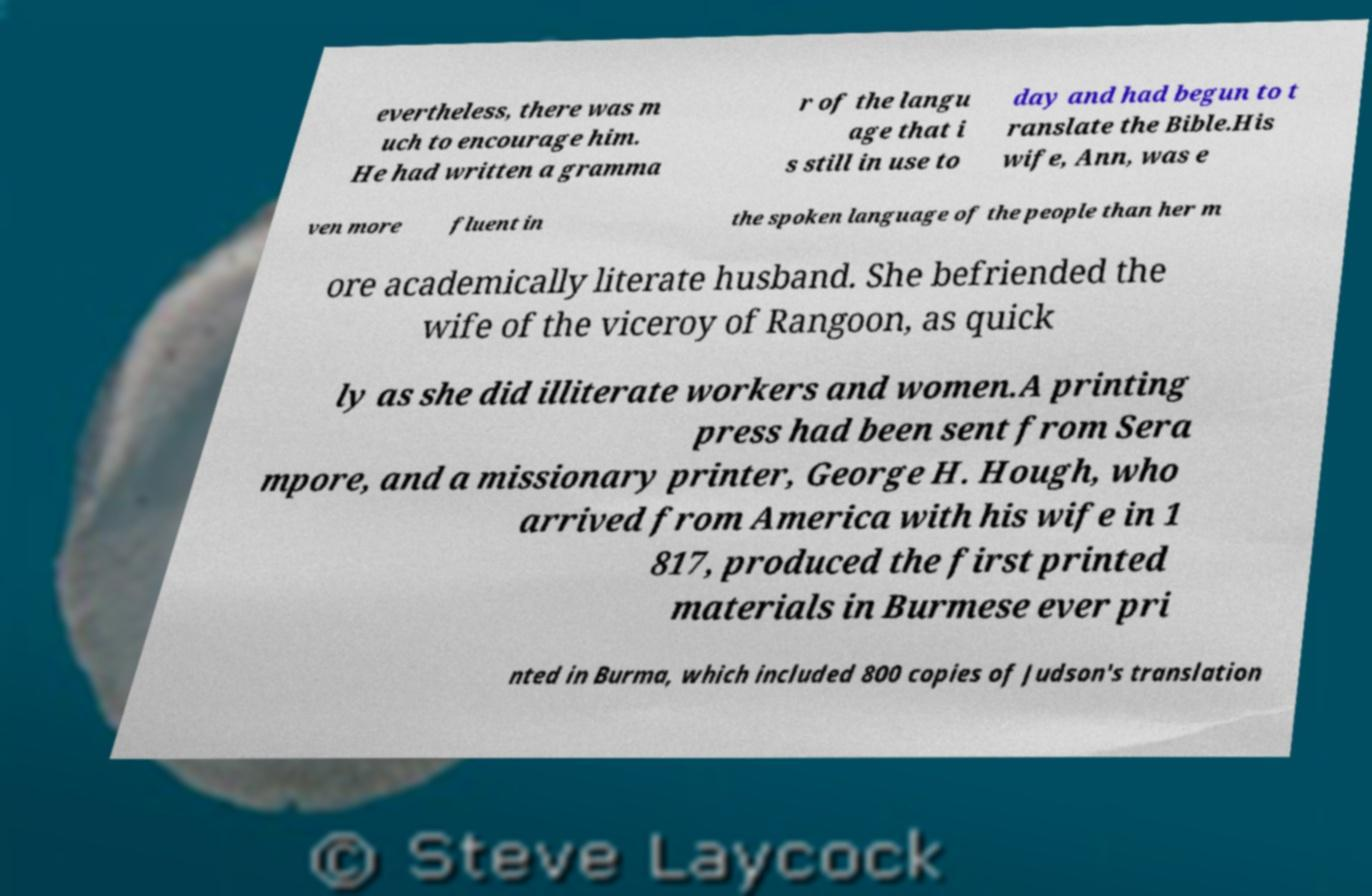For documentation purposes, I need the text within this image transcribed. Could you provide that? evertheless, there was m uch to encourage him. He had written a gramma r of the langu age that i s still in use to day and had begun to t ranslate the Bible.His wife, Ann, was e ven more fluent in the spoken language of the people than her m ore academically literate husband. She befriended the wife of the viceroy of Rangoon, as quick ly as she did illiterate workers and women.A printing press had been sent from Sera mpore, and a missionary printer, George H. Hough, who arrived from America with his wife in 1 817, produced the first printed materials in Burmese ever pri nted in Burma, which included 800 copies of Judson's translation 